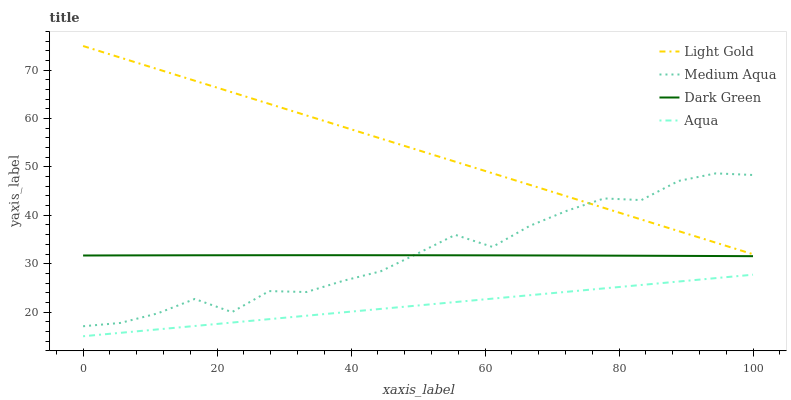Does Aqua have the minimum area under the curve?
Answer yes or no. Yes. Does Light Gold have the maximum area under the curve?
Answer yes or no. Yes. Does Medium Aqua have the minimum area under the curve?
Answer yes or no. No. Does Medium Aqua have the maximum area under the curve?
Answer yes or no. No. Is Aqua the smoothest?
Answer yes or no. Yes. Is Medium Aqua the roughest?
Answer yes or no. Yes. Is Light Gold the smoothest?
Answer yes or no. No. Is Light Gold the roughest?
Answer yes or no. No. Does Aqua have the lowest value?
Answer yes or no. Yes. Does Medium Aqua have the lowest value?
Answer yes or no. No. Does Light Gold have the highest value?
Answer yes or no. Yes. Does Medium Aqua have the highest value?
Answer yes or no. No. Is Aqua less than Dark Green?
Answer yes or no. Yes. Is Dark Green greater than Aqua?
Answer yes or no. Yes. Does Medium Aqua intersect Dark Green?
Answer yes or no. Yes. Is Medium Aqua less than Dark Green?
Answer yes or no. No. Is Medium Aqua greater than Dark Green?
Answer yes or no. No. Does Aqua intersect Dark Green?
Answer yes or no. No. 